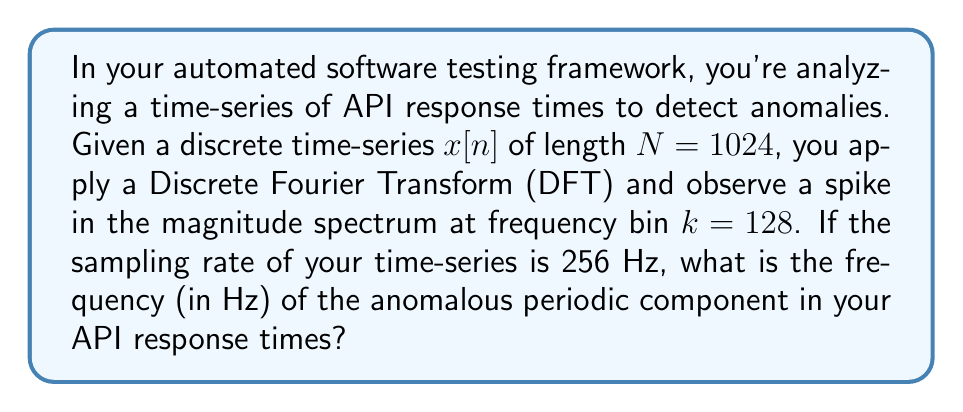Help me with this question. Let's approach this step-by-step:

1) The Discrete Fourier Transform (DFT) of a time-series $x[n]$ is given by:

   $$X[k] = \sum_{n=0}^{N-1} x[n] e^{-j2\pi kn/N}$$

   where $k$ is the frequency bin index.

2) The frequency resolution of the DFT is given by:

   $$\Delta f = \frac{f_s}{N}$$

   where $f_s$ is the sampling frequency and $N$ is the number of samples.

3) In this case:
   $f_s = 256$ Hz
   $N = 1024$

4) So, the frequency resolution is:

   $$\Delta f = \frac{256}{1024} = 0.25\text{ Hz}$$

5) The frequency corresponding to a given bin $k$ is:

   $$f = k \cdot \Delta f$$

6) We observed a spike at $k = 128$, so the frequency is:

   $$f = 128 \cdot 0.25 = 32\text{ Hz}$$

Therefore, the anomalous periodic component in the API response times has a frequency of 32 Hz.
Answer: 32 Hz 